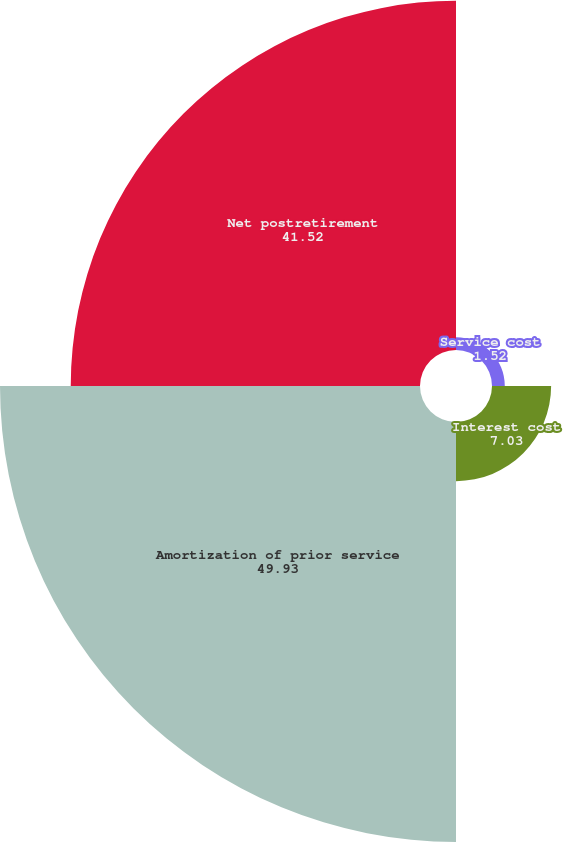Convert chart. <chart><loc_0><loc_0><loc_500><loc_500><pie_chart><fcel>Service cost<fcel>Interest cost<fcel>Amortization of prior service<fcel>Net postretirement<nl><fcel>1.52%<fcel>7.03%<fcel>49.93%<fcel>41.52%<nl></chart> 